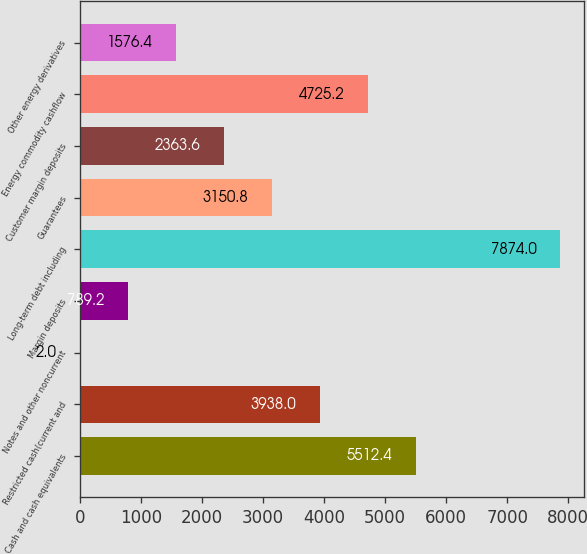Convert chart. <chart><loc_0><loc_0><loc_500><loc_500><bar_chart><fcel>Cash and cash equivalents<fcel>Restricted cash(current and<fcel>Notes and other noncurrent<fcel>Margin deposits<fcel>Long-term debt including<fcel>Guarantees<fcel>Customer margin deposits<fcel>Energy commodity cashflow<fcel>Other energy derivatives<nl><fcel>5512.4<fcel>3938<fcel>2<fcel>789.2<fcel>7874<fcel>3150.8<fcel>2363.6<fcel>4725.2<fcel>1576.4<nl></chart> 